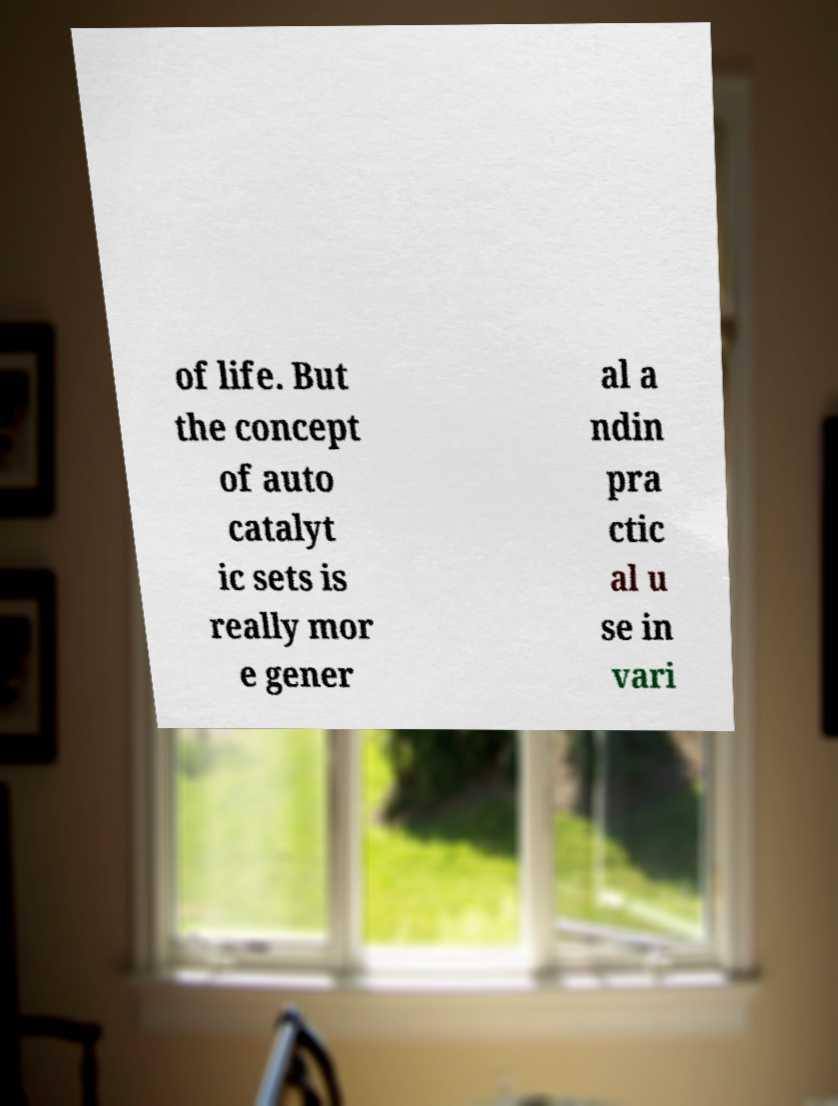Could you extract and type out the text from this image? of life. But the concept of auto catalyt ic sets is really mor e gener al a ndin pra ctic al u se in vari 